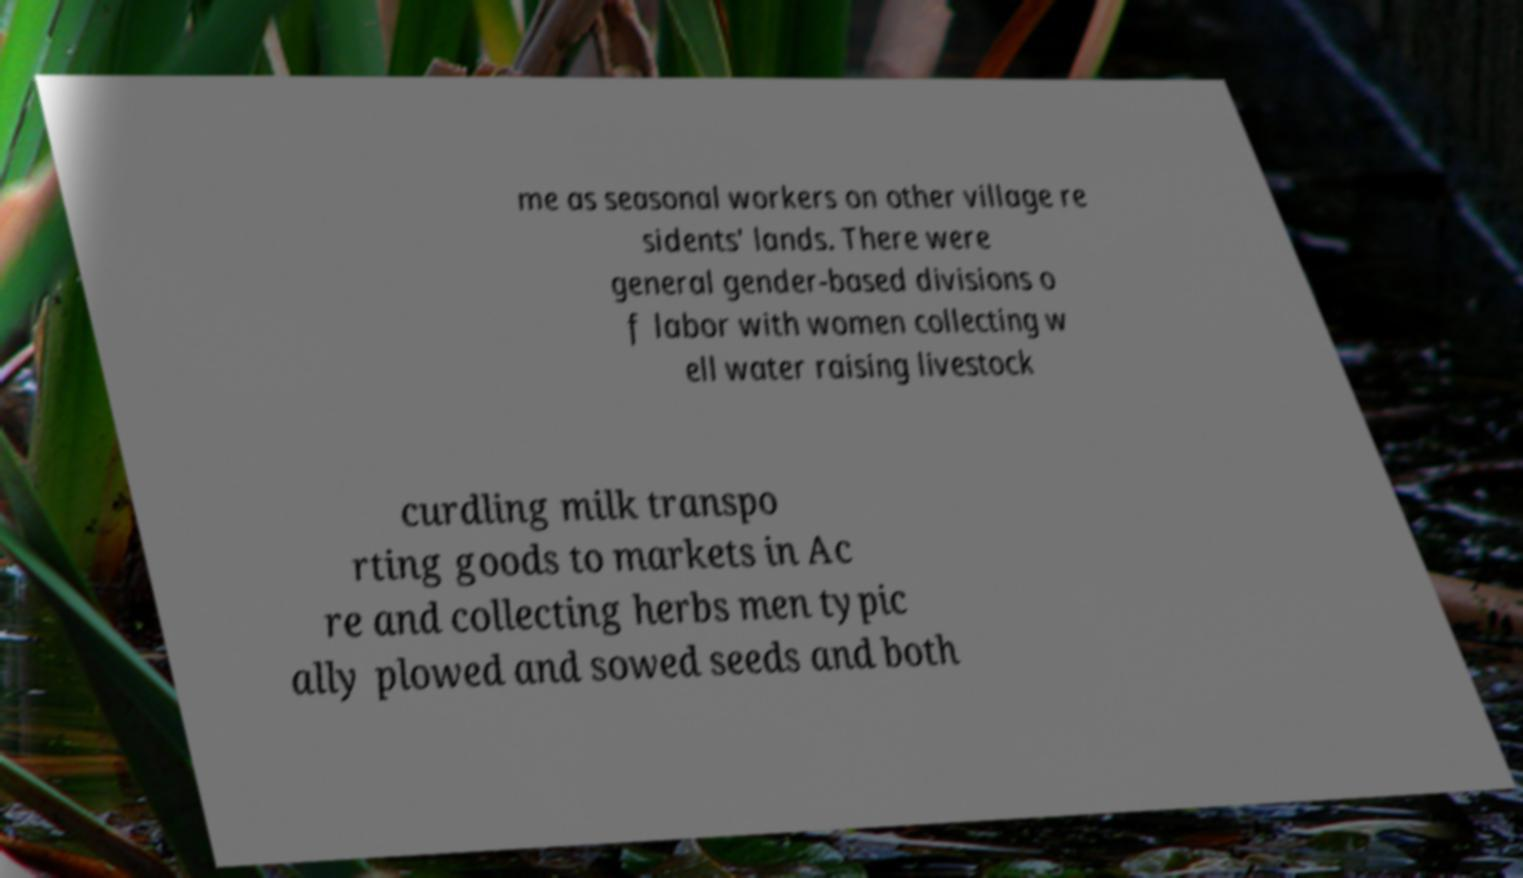Can you read and provide the text displayed in the image?This photo seems to have some interesting text. Can you extract and type it out for me? me as seasonal workers on other village re sidents' lands. There were general gender-based divisions o f labor with women collecting w ell water raising livestock curdling milk transpo rting goods to markets in Ac re and collecting herbs men typic ally plowed and sowed seeds and both 